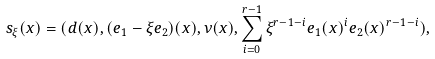Convert formula to latex. <formula><loc_0><loc_0><loc_500><loc_500>s _ { \xi } ( x ) = ( d ( x ) , ( e _ { 1 } - \xi e _ { 2 } ) ( x ) , \nu ( x ) , \sum _ { i = 0 } ^ { r - 1 } \xi ^ { r - 1 - i } e _ { 1 } ( x ) ^ { i } e _ { 2 } ( x ) ^ { r - 1 - i } ) ,</formula> 